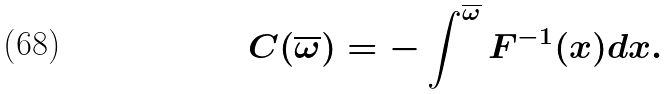<formula> <loc_0><loc_0><loc_500><loc_500>C ( \overline { \omega } ) = - \int ^ { \overline { \omega } } F ^ { - 1 } ( x ) d x .</formula> 